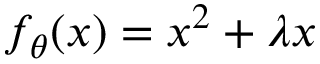<formula> <loc_0><loc_0><loc_500><loc_500>f _ { \theta } ( x ) = x ^ { 2 } + \lambda x</formula> 